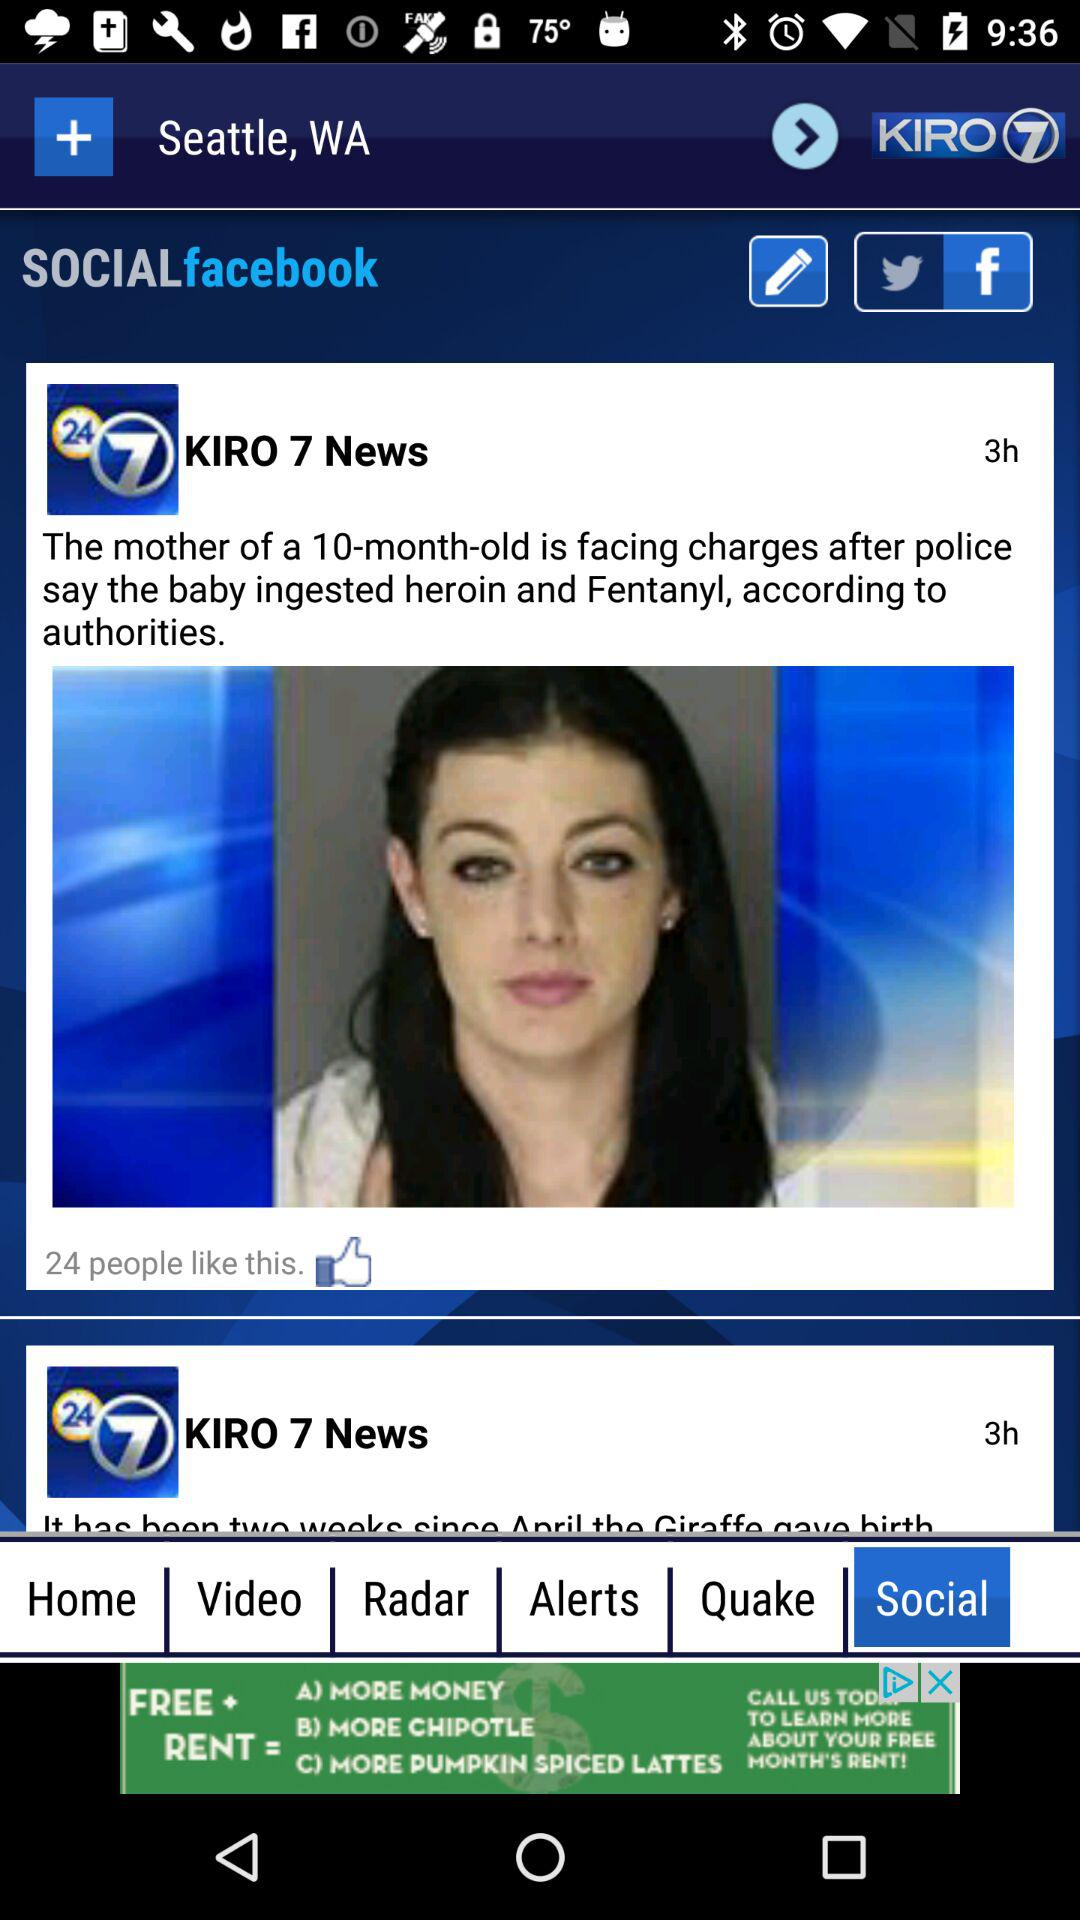How many hours ago was the first article published?
Answer the question using a single word or phrase. 3 